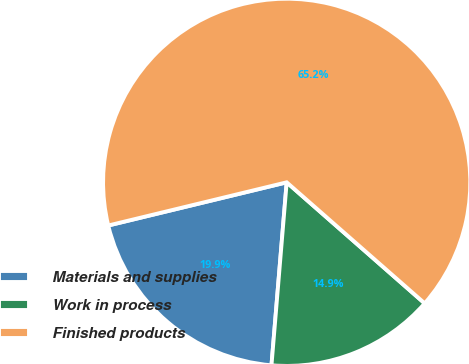Convert chart. <chart><loc_0><loc_0><loc_500><loc_500><pie_chart><fcel>Materials and supplies<fcel>Work in process<fcel>Finished products<nl><fcel>19.9%<fcel>14.86%<fcel>65.24%<nl></chart> 